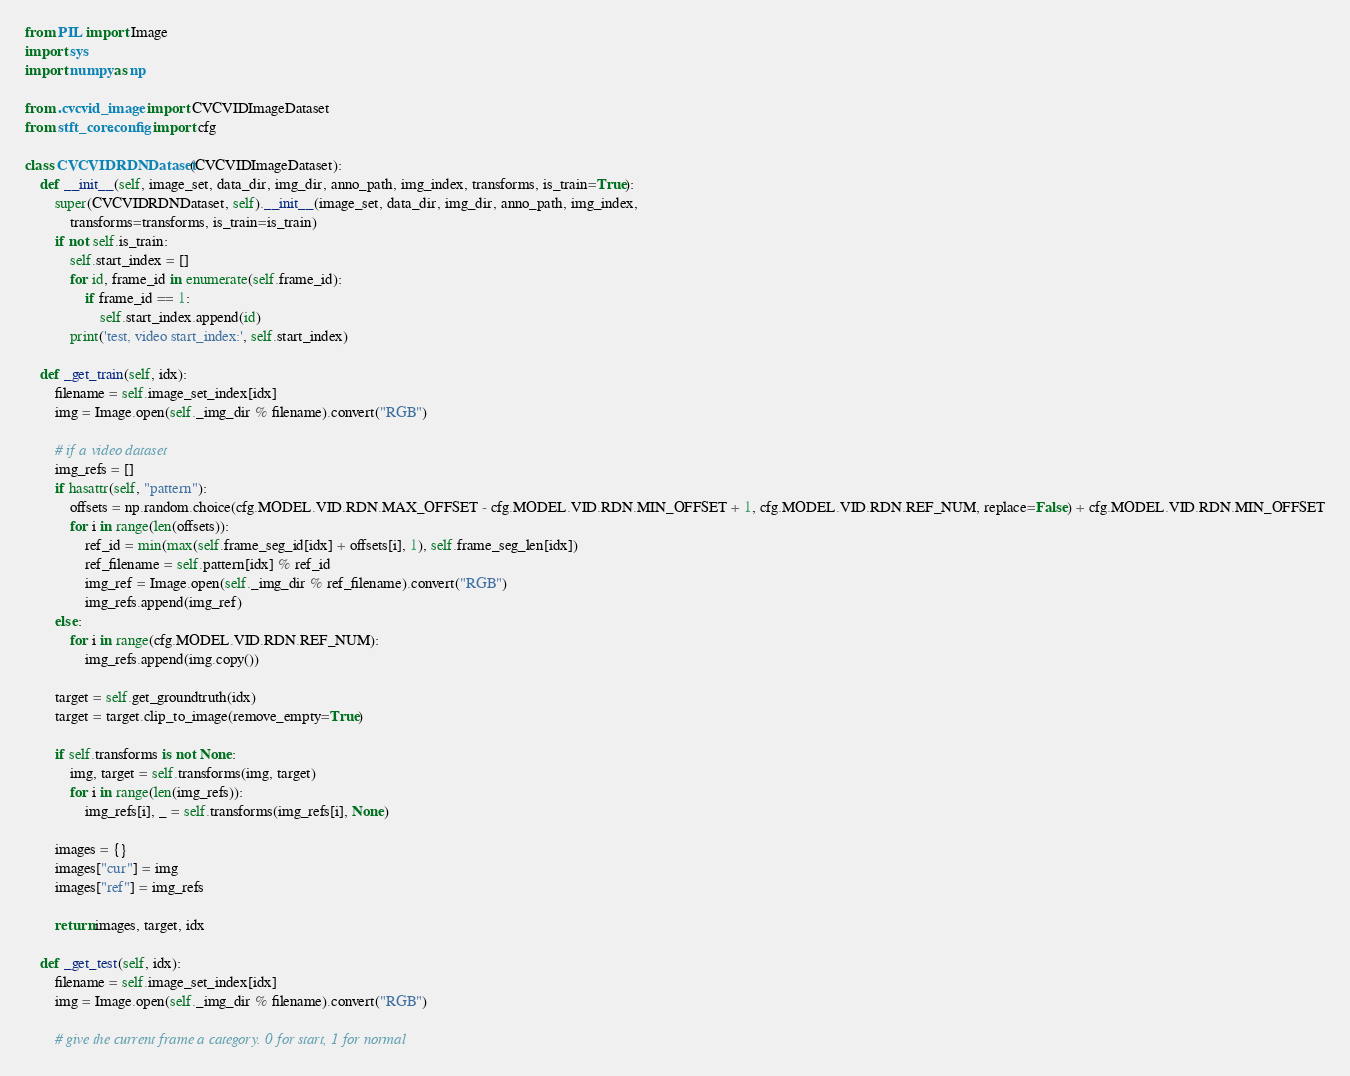<code> <loc_0><loc_0><loc_500><loc_500><_Python_>from PIL import Image
import sys
import numpy as np

from .cvcvid_image import CVCVIDImageDataset
from stft_core.config import cfg

class CVCVIDRDNDataset(CVCVIDImageDataset):
    def __init__(self, image_set, data_dir, img_dir, anno_path, img_index, transforms, is_train=True):
        super(CVCVIDRDNDataset, self).__init__(image_set, data_dir, img_dir, anno_path, img_index, 
            transforms=transforms, is_train=is_train)
        if not self.is_train:
            self.start_index = []
            for id, frame_id in enumerate(self.frame_id):
                if frame_id == 1:
                    self.start_index.append(id)
            print('test, video start_index:', self.start_index)

    def _get_train(self, idx):
        filename = self.image_set_index[idx]
        img = Image.open(self._img_dir % filename).convert("RGB")

        # if a video dataset
        img_refs = []
        if hasattr(self, "pattern"):
            offsets = np.random.choice(cfg.MODEL.VID.RDN.MAX_OFFSET - cfg.MODEL.VID.RDN.MIN_OFFSET + 1, cfg.MODEL.VID.RDN.REF_NUM, replace=False) + cfg.MODEL.VID.RDN.MIN_OFFSET
            for i in range(len(offsets)):
                ref_id = min(max(self.frame_seg_id[idx] + offsets[i], 1), self.frame_seg_len[idx])
                ref_filename = self.pattern[idx] % ref_id
                img_ref = Image.open(self._img_dir % ref_filename).convert("RGB")
                img_refs.append(img_ref)
        else:
            for i in range(cfg.MODEL.VID.RDN.REF_NUM):
                img_refs.append(img.copy())

        target = self.get_groundtruth(idx)
        target = target.clip_to_image(remove_empty=True)

        if self.transforms is not None:
            img, target = self.transforms(img, target)
            for i in range(len(img_refs)):
                img_refs[i], _ = self.transforms(img_refs[i], None)

        images = {}
        images["cur"] = img
        images["ref"] = img_refs

        return images, target, idx

    def _get_test(self, idx):
        filename = self.image_set_index[idx]
        img = Image.open(self._img_dir % filename).convert("RGB")

        # give the current frame a category. 0 for start, 1 for normal</code> 